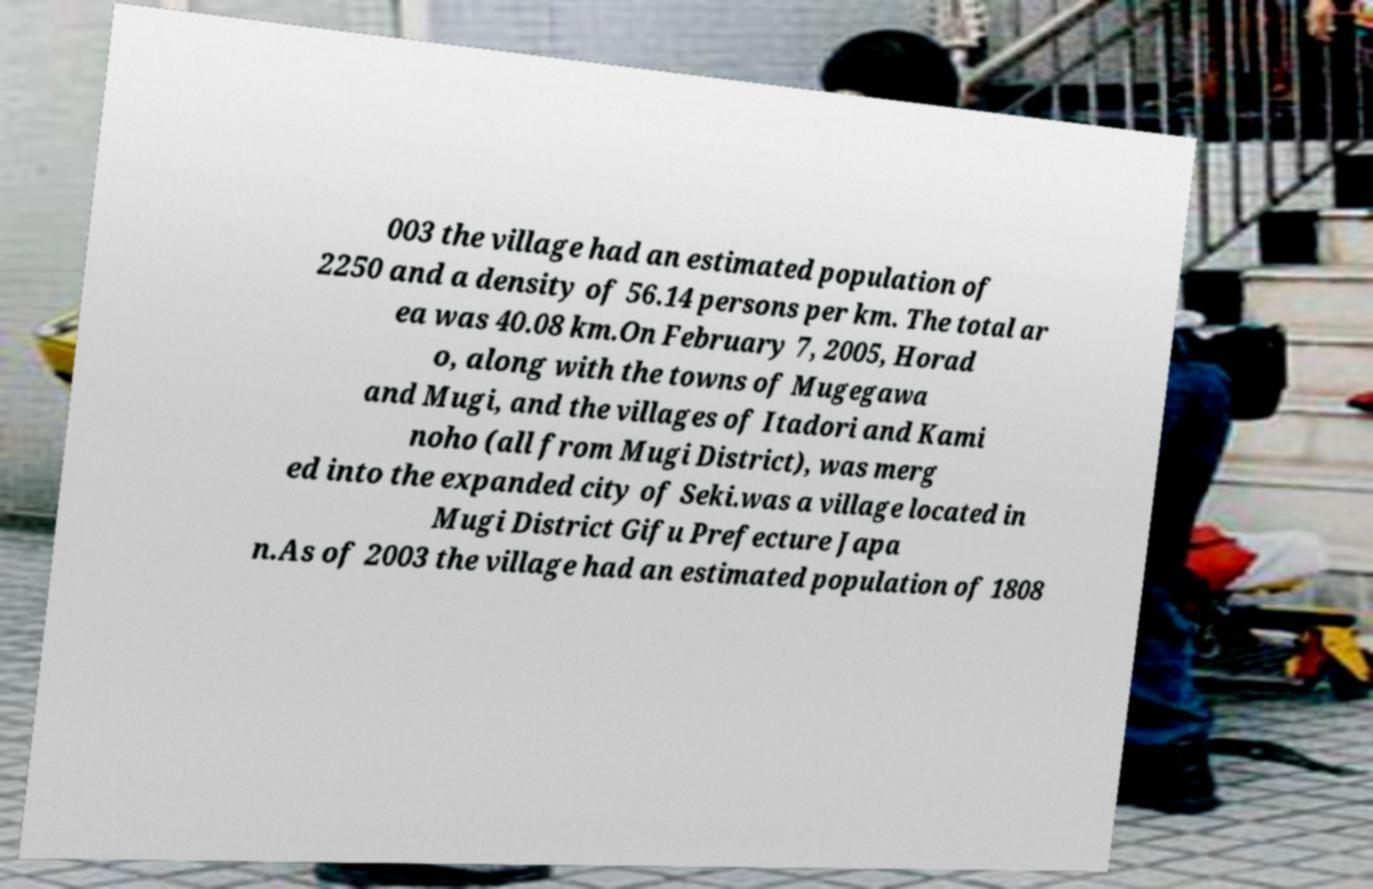I need the written content from this picture converted into text. Can you do that? 003 the village had an estimated population of 2250 and a density of 56.14 persons per km. The total ar ea was 40.08 km.On February 7, 2005, Horad o, along with the towns of Mugegawa and Mugi, and the villages of Itadori and Kami noho (all from Mugi District), was merg ed into the expanded city of Seki.was a village located in Mugi District Gifu Prefecture Japa n.As of 2003 the village had an estimated population of 1808 